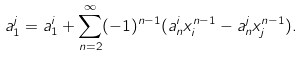<formula> <loc_0><loc_0><loc_500><loc_500>a _ { 1 } ^ { j } = a _ { 1 } ^ { i } + \sum _ { n = 2 } ^ { \infty } ( - 1 ) ^ { n - 1 } ( a _ { n } ^ { i } x _ { i } ^ { n - 1 } - a _ { n } ^ { j } x _ { j } ^ { n - 1 } ) .</formula> 